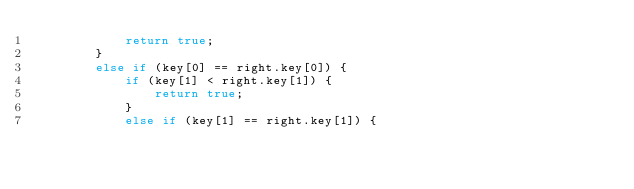<code> <loc_0><loc_0><loc_500><loc_500><_C++_>            return true;
        }
        else if (key[0] == right.key[0]) {
            if (key[1] < right.key[1]) {
                return true;
            }
            else if (key[1] == right.key[1]) {</code> 